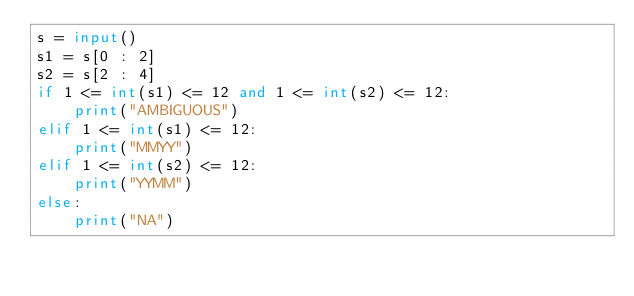Convert code to text. <code><loc_0><loc_0><loc_500><loc_500><_Python_>s = input()
s1 = s[0 : 2]
s2 = s[2 : 4]
if 1 <= int(s1) <= 12 and 1 <= int(s2) <= 12:
    print("AMBIGUOUS")
elif 1 <= int(s1) <= 12:
    print("MMYY")
elif 1 <= int(s2) <= 12:
    print("YYMM")
else:
    print("NA")</code> 